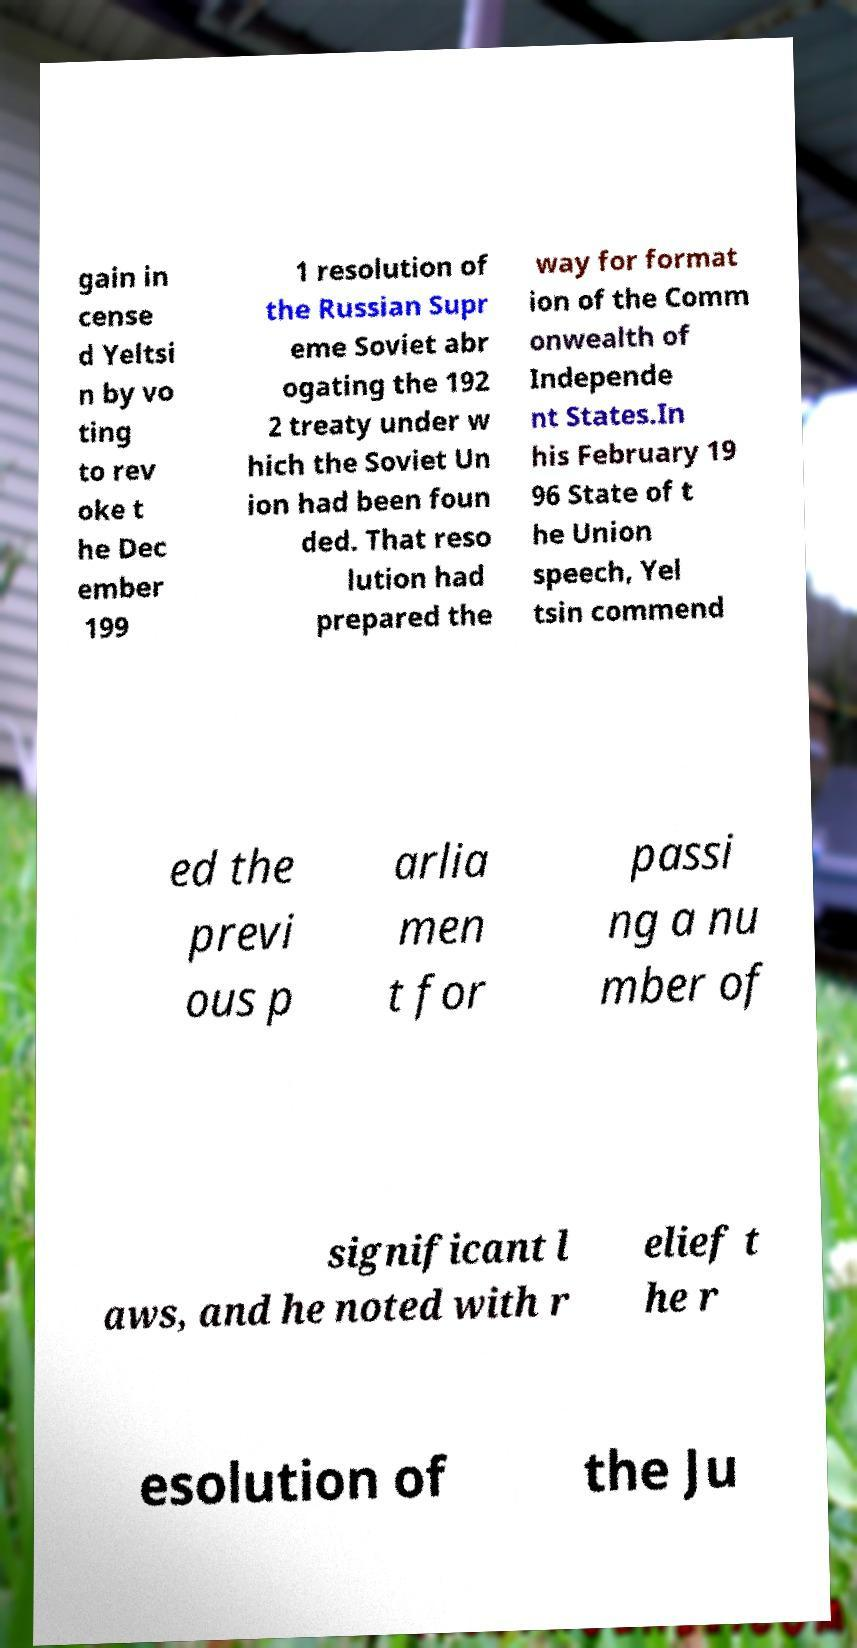Please identify and transcribe the text found in this image. gain in cense d Yeltsi n by vo ting to rev oke t he Dec ember 199 1 resolution of the Russian Supr eme Soviet abr ogating the 192 2 treaty under w hich the Soviet Un ion had been foun ded. That reso lution had prepared the way for format ion of the Comm onwealth of Independe nt States.In his February 19 96 State of t he Union speech, Yel tsin commend ed the previ ous p arlia men t for passi ng a nu mber of significant l aws, and he noted with r elief t he r esolution of the Ju 